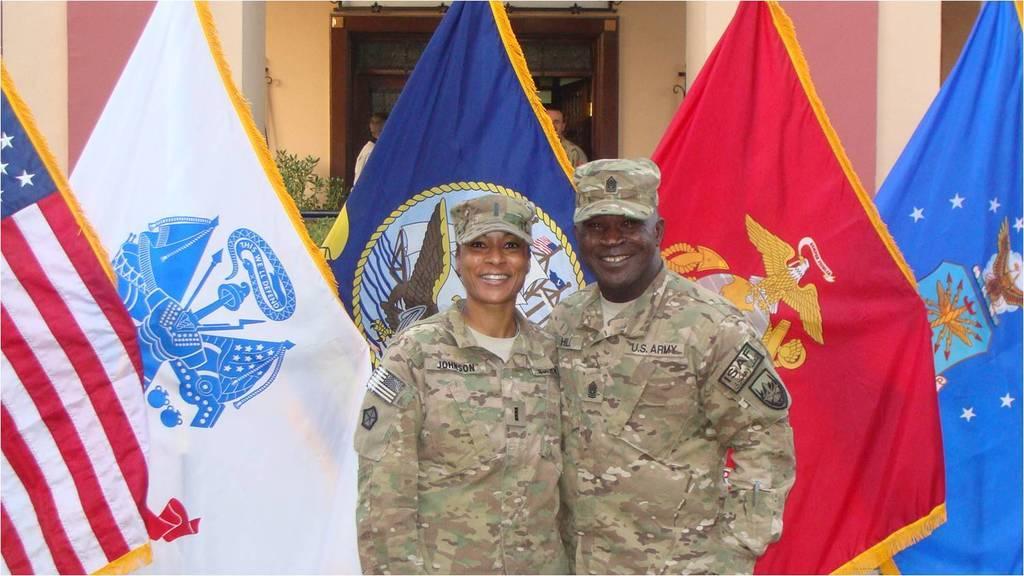Could you give a brief overview of what you see in this image? In this image I can see two persons wearing military uniforms are standing. In the background I can see few flags, few persons, a plant and a building. 